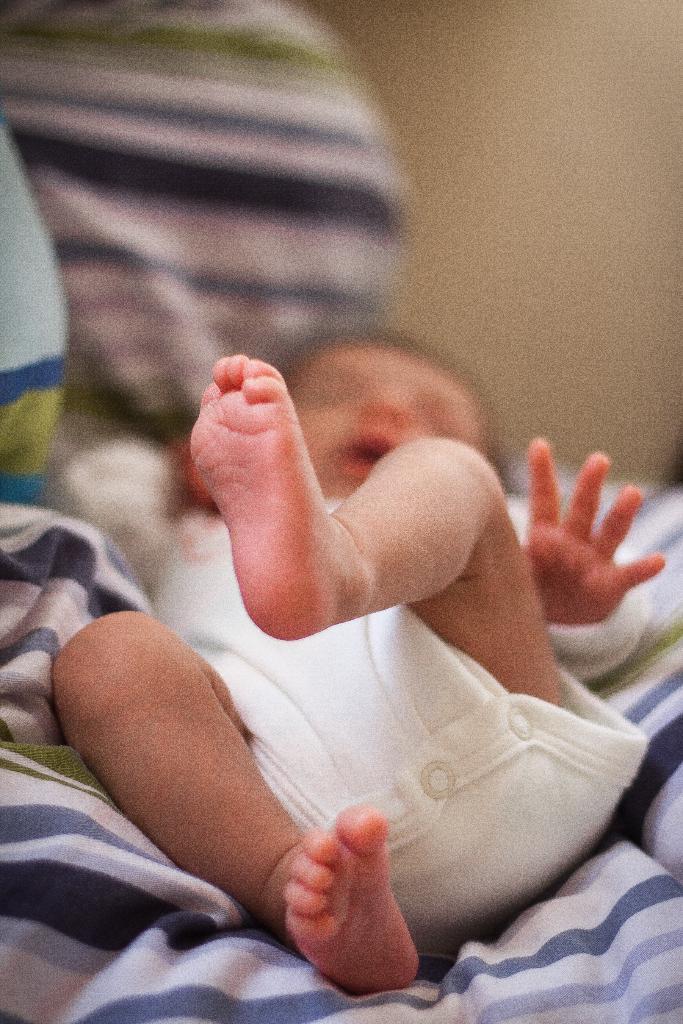Could you give a brief overview of what you see in this image? There is a baby in white color dress, laying on a bed sheet. In the background, there is wall. 